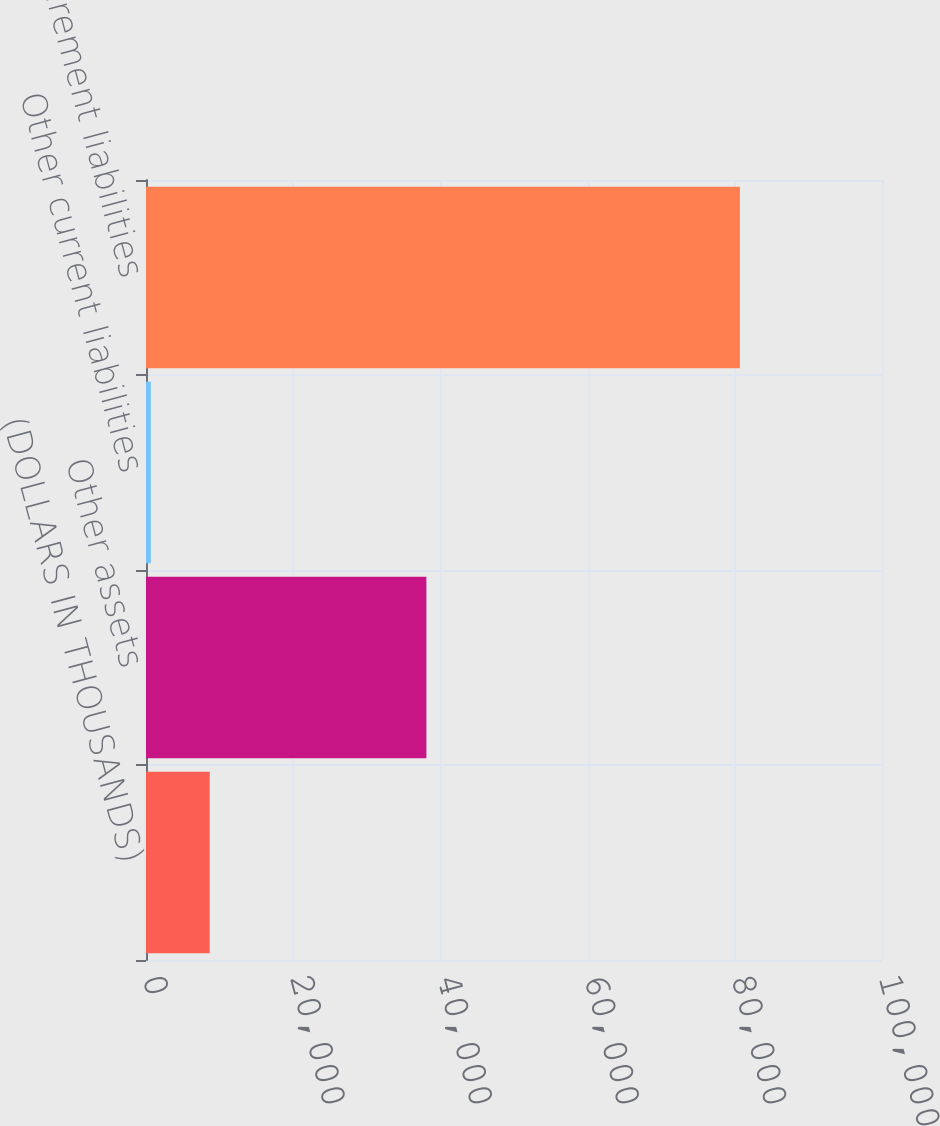<chart> <loc_0><loc_0><loc_500><loc_500><bar_chart><fcel>(DOLLARS IN THOUSANDS)<fcel>Other assets<fcel>Other current liabilities<fcel>Retirement liabilities<nl><fcel>8656.2<fcel>38095<fcel>652<fcel>80694<nl></chart> 